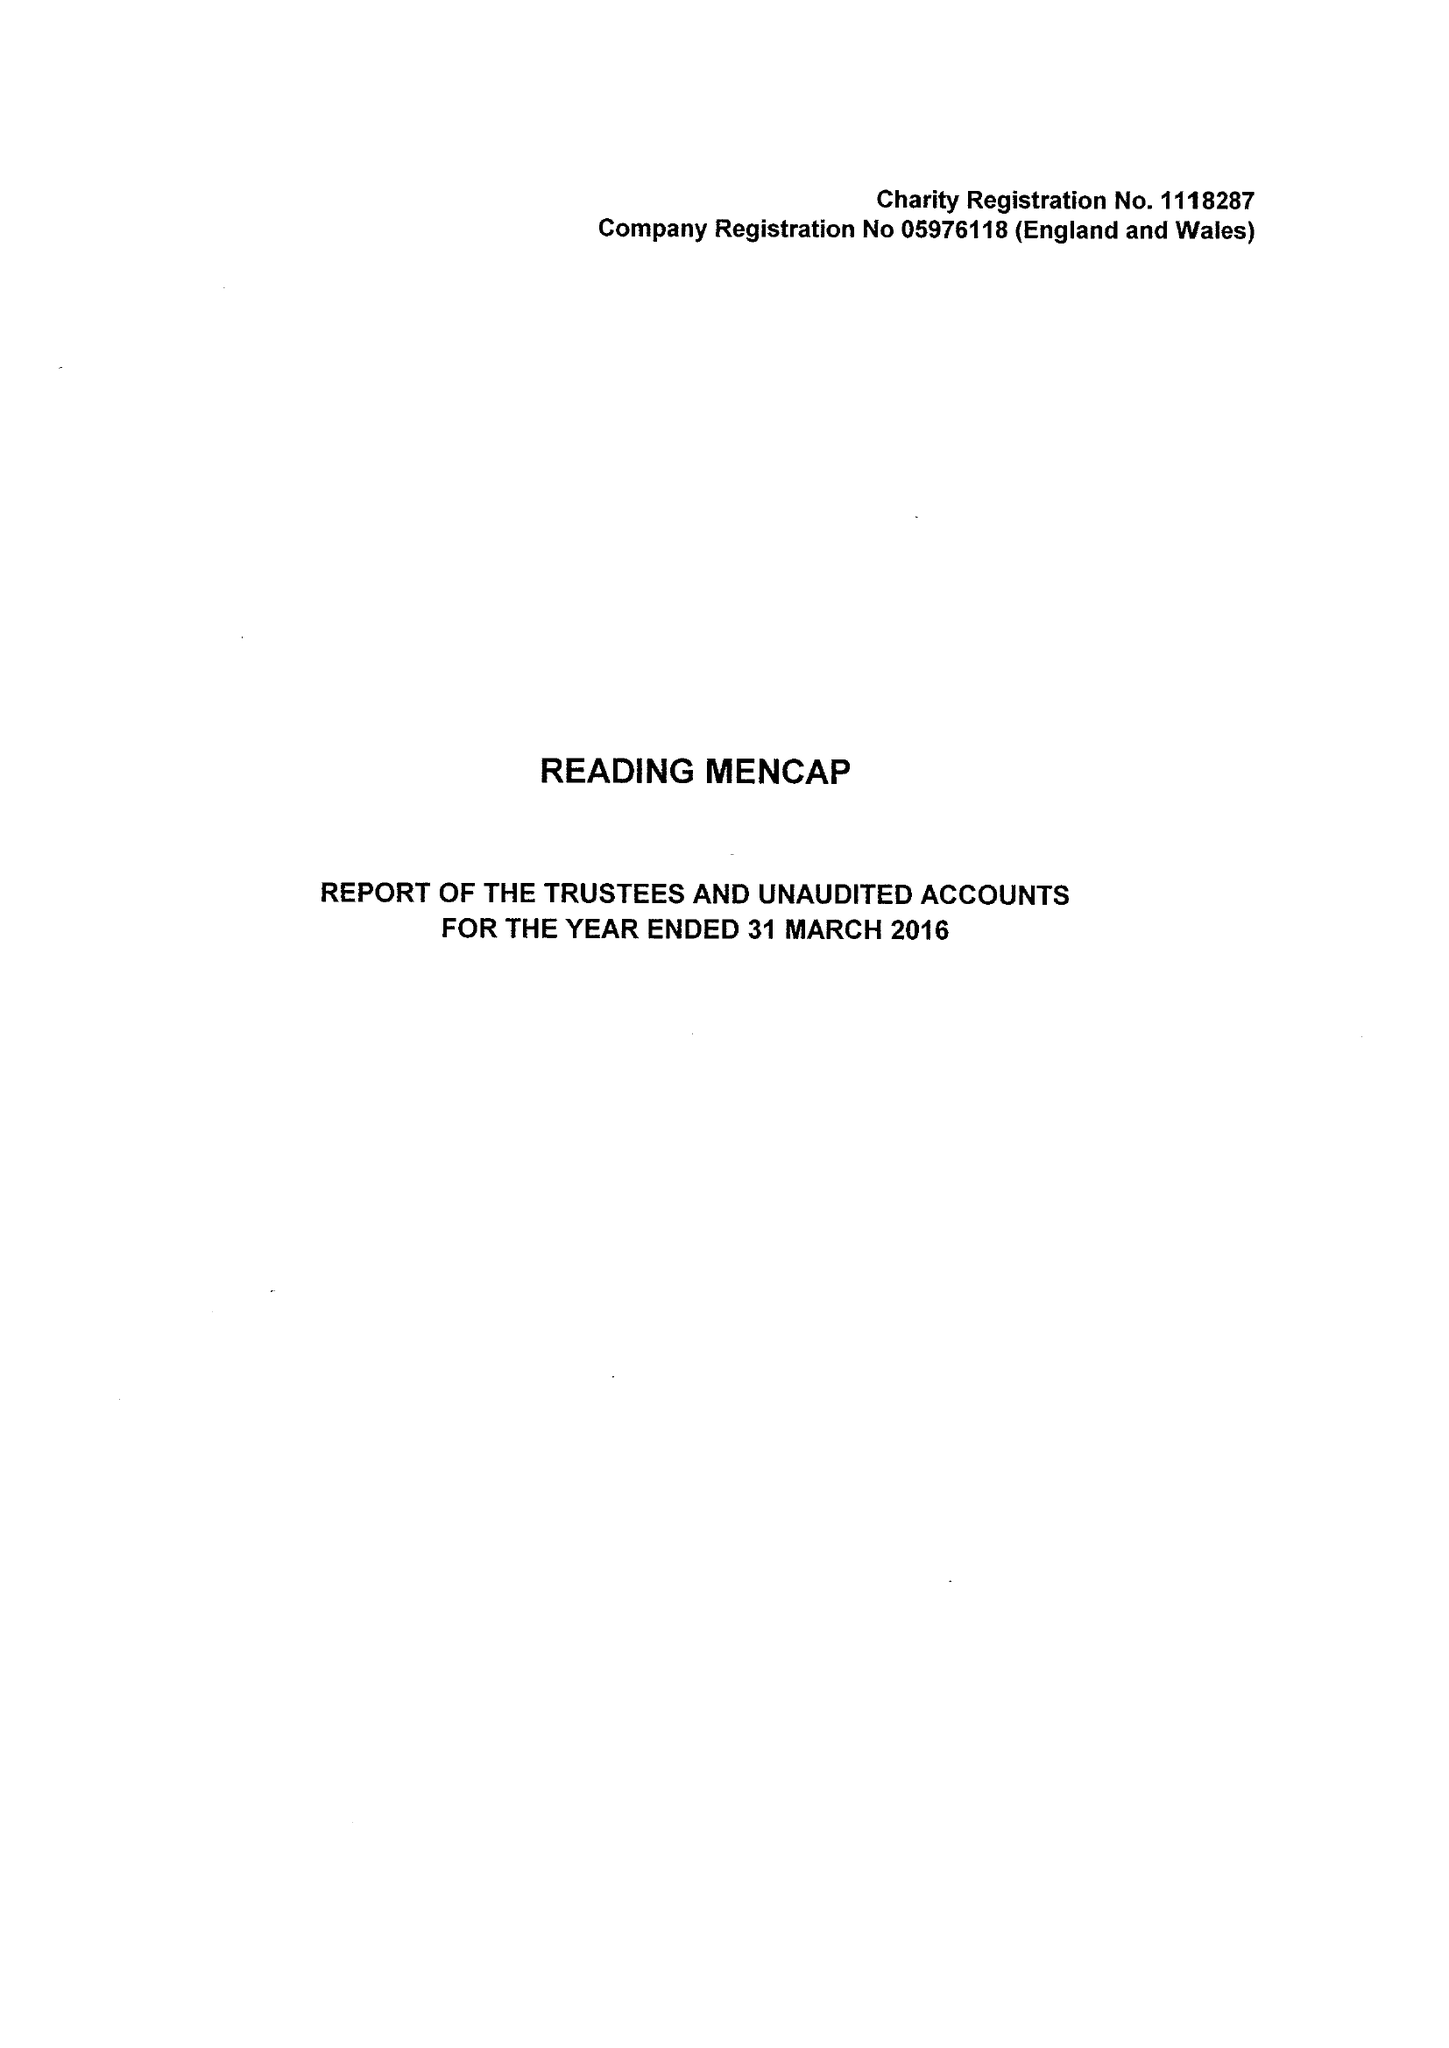What is the value for the address__street_line?
Answer the question using a single word or phrase. 21 ALEXANDRA ROAD 